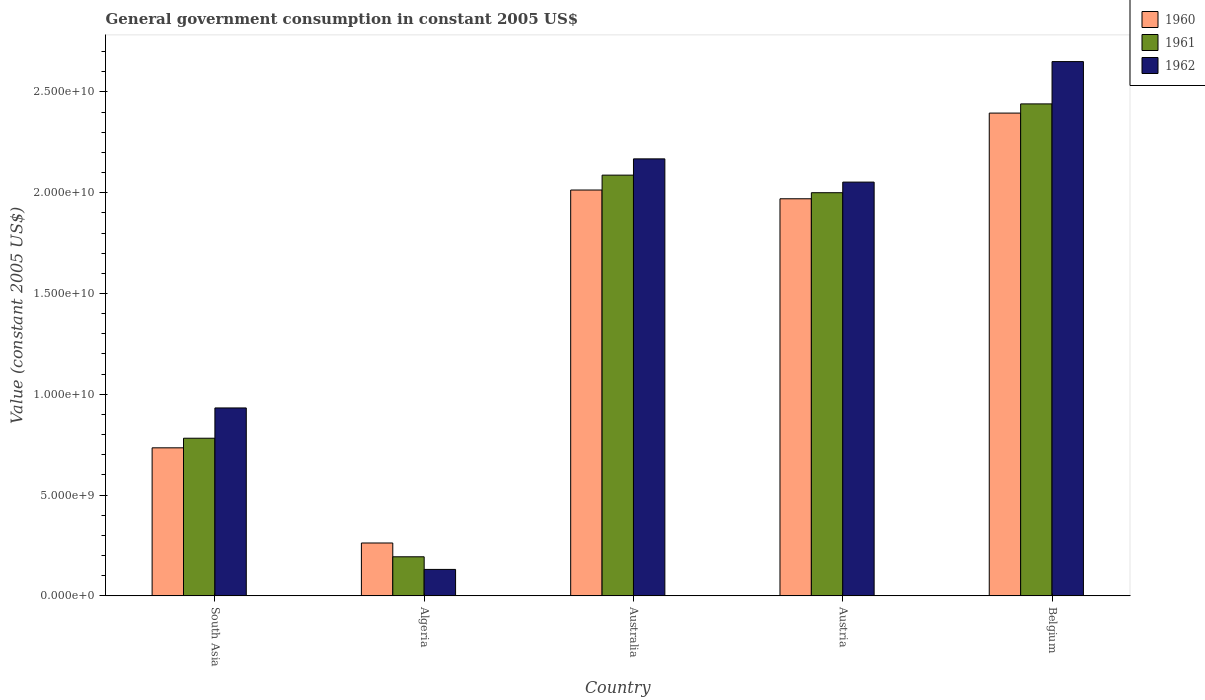How many different coloured bars are there?
Provide a succinct answer. 3. How many groups of bars are there?
Your answer should be very brief. 5. Are the number of bars on each tick of the X-axis equal?
Your answer should be compact. Yes. How many bars are there on the 4th tick from the right?
Provide a short and direct response. 3. In how many cases, is the number of bars for a given country not equal to the number of legend labels?
Your answer should be compact. 0. What is the government conusmption in 1960 in Belgium?
Your response must be concise. 2.40e+1. Across all countries, what is the maximum government conusmption in 1961?
Offer a very short reply. 2.44e+1. Across all countries, what is the minimum government conusmption in 1962?
Keep it short and to the point. 1.31e+09. In which country was the government conusmption in 1962 maximum?
Keep it short and to the point. Belgium. In which country was the government conusmption in 1960 minimum?
Your answer should be very brief. Algeria. What is the total government conusmption in 1960 in the graph?
Give a very brief answer. 7.38e+1. What is the difference between the government conusmption in 1961 in Australia and that in Austria?
Provide a short and direct response. 8.72e+08. What is the difference between the government conusmption in 1960 in Australia and the government conusmption in 1961 in Belgium?
Make the answer very short. -4.27e+09. What is the average government conusmption in 1962 per country?
Your answer should be compact. 1.59e+1. What is the difference between the government conusmption of/in 1962 and government conusmption of/in 1960 in South Asia?
Make the answer very short. 1.98e+09. In how many countries, is the government conusmption in 1962 greater than 12000000000 US$?
Make the answer very short. 3. What is the ratio of the government conusmption in 1960 in Algeria to that in Austria?
Give a very brief answer. 0.13. Is the government conusmption in 1960 in Austria less than that in South Asia?
Keep it short and to the point. No. Is the difference between the government conusmption in 1962 in Algeria and Austria greater than the difference between the government conusmption in 1960 in Algeria and Austria?
Ensure brevity in your answer.  No. What is the difference between the highest and the second highest government conusmption in 1960?
Offer a very short reply. 4.25e+09. What is the difference between the highest and the lowest government conusmption in 1960?
Offer a very short reply. 2.13e+1. Is the sum of the government conusmption in 1961 in Algeria and Austria greater than the maximum government conusmption in 1960 across all countries?
Offer a very short reply. No. What does the 2nd bar from the left in Austria represents?
Provide a short and direct response. 1961. Is it the case that in every country, the sum of the government conusmption in 1961 and government conusmption in 1962 is greater than the government conusmption in 1960?
Ensure brevity in your answer.  Yes. How many bars are there?
Your response must be concise. 15. How many countries are there in the graph?
Keep it short and to the point. 5. What is the difference between two consecutive major ticks on the Y-axis?
Your response must be concise. 5.00e+09. Does the graph contain any zero values?
Offer a terse response. No. Does the graph contain grids?
Ensure brevity in your answer.  No. Where does the legend appear in the graph?
Your response must be concise. Top right. How many legend labels are there?
Give a very brief answer. 3. How are the legend labels stacked?
Your response must be concise. Vertical. What is the title of the graph?
Provide a short and direct response. General government consumption in constant 2005 US$. What is the label or title of the Y-axis?
Give a very brief answer. Value (constant 2005 US$). What is the Value (constant 2005 US$) of 1960 in South Asia?
Your answer should be very brief. 7.34e+09. What is the Value (constant 2005 US$) of 1961 in South Asia?
Your answer should be compact. 7.82e+09. What is the Value (constant 2005 US$) of 1962 in South Asia?
Provide a short and direct response. 9.32e+09. What is the Value (constant 2005 US$) in 1960 in Algeria?
Ensure brevity in your answer.  2.62e+09. What is the Value (constant 2005 US$) in 1961 in Algeria?
Ensure brevity in your answer.  1.94e+09. What is the Value (constant 2005 US$) of 1962 in Algeria?
Provide a short and direct response. 1.31e+09. What is the Value (constant 2005 US$) of 1960 in Australia?
Your response must be concise. 2.01e+1. What is the Value (constant 2005 US$) in 1961 in Australia?
Your response must be concise. 2.09e+1. What is the Value (constant 2005 US$) of 1962 in Australia?
Make the answer very short. 2.17e+1. What is the Value (constant 2005 US$) in 1960 in Austria?
Make the answer very short. 1.97e+1. What is the Value (constant 2005 US$) of 1961 in Austria?
Offer a very short reply. 2.00e+1. What is the Value (constant 2005 US$) in 1962 in Austria?
Make the answer very short. 2.05e+1. What is the Value (constant 2005 US$) of 1960 in Belgium?
Ensure brevity in your answer.  2.40e+1. What is the Value (constant 2005 US$) in 1961 in Belgium?
Provide a succinct answer. 2.44e+1. What is the Value (constant 2005 US$) in 1962 in Belgium?
Offer a very short reply. 2.65e+1. Across all countries, what is the maximum Value (constant 2005 US$) of 1960?
Offer a terse response. 2.40e+1. Across all countries, what is the maximum Value (constant 2005 US$) in 1961?
Your answer should be compact. 2.44e+1. Across all countries, what is the maximum Value (constant 2005 US$) in 1962?
Make the answer very short. 2.65e+1. Across all countries, what is the minimum Value (constant 2005 US$) in 1960?
Your answer should be compact. 2.62e+09. Across all countries, what is the minimum Value (constant 2005 US$) of 1961?
Give a very brief answer. 1.94e+09. Across all countries, what is the minimum Value (constant 2005 US$) of 1962?
Give a very brief answer. 1.31e+09. What is the total Value (constant 2005 US$) of 1960 in the graph?
Ensure brevity in your answer.  7.38e+1. What is the total Value (constant 2005 US$) in 1961 in the graph?
Give a very brief answer. 7.50e+1. What is the total Value (constant 2005 US$) of 1962 in the graph?
Provide a short and direct response. 7.94e+1. What is the difference between the Value (constant 2005 US$) of 1960 in South Asia and that in Algeria?
Your response must be concise. 4.72e+09. What is the difference between the Value (constant 2005 US$) in 1961 in South Asia and that in Algeria?
Your answer should be compact. 5.88e+09. What is the difference between the Value (constant 2005 US$) in 1962 in South Asia and that in Algeria?
Your response must be concise. 8.01e+09. What is the difference between the Value (constant 2005 US$) in 1960 in South Asia and that in Australia?
Your answer should be very brief. -1.28e+1. What is the difference between the Value (constant 2005 US$) of 1961 in South Asia and that in Australia?
Provide a short and direct response. -1.31e+1. What is the difference between the Value (constant 2005 US$) of 1962 in South Asia and that in Australia?
Your answer should be very brief. -1.24e+1. What is the difference between the Value (constant 2005 US$) of 1960 in South Asia and that in Austria?
Offer a terse response. -1.24e+1. What is the difference between the Value (constant 2005 US$) of 1961 in South Asia and that in Austria?
Provide a succinct answer. -1.22e+1. What is the difference between the Value (constant 2005 US$) in 1962 in South Asia and that in Austria?
Offer a terse response. -1.12e+1. What is the difference between the Value (constant 2005 US$) of 1960 in South Asia and that in Belgium?
Give a very brief answer. -1.66e+1. What is the difference between the Value (constant 2005 US$) in 1961 in South Asia and that in Belgium?
Offer a terse response. -1.66e+1. What is the difference between the Value (constant 2005 US$) of 1962 in South Asia and that in Belgium?
Ensure brevity in your answer.  -1.72e+1. What is the difference between the Value (constant 2005 US$) in 1960 in Algeria and that in Australia?
Your answer should be very brief. -1.75e+1. What is the difference between the Value (constant 2005 US$) of 1961 in Algeria and that in Australia?
Make the answer very short. -1.89e+1. What is the difference between the Value (constant 2005 US$) in 1962 in Algeria and that in Australia?
Make the answer very short. -2.04e+1. What is the difference between the Value (constant 2005 US$) of 1960 in Algeria and that in Austria?
Ensure brevity in your answer.  -1.71e+1. What is the difference between the Value (constant 2005 US$) in 1961 in Algeria and that in Austria?
Keep it short and to the point. -1.81e+1. What is the difference between the Value (constant 2005 US$) of 1962 in Algeria and that in Austria?
Provide a short and direct response. -1.92e+1. What is the difference between the Value (constant 2005 US$) of 1960 in Algeria and that in Belgium?
Provide a short and direct response. -2.13e+1. What is the difference between the Value (constant 2005 US$) in 1961 in Algeria and that in Belgium?
Provide a short and direct response. -2.25e+1. What is the difference between the Value (constant 2005 US$) in 1962 in Algeria and that in Belgium?
Your answer should be very brief. -2.52e+1. What is the difference between the Value (constant 2005 US$) of 1960 in Australia and that in Austria?
Your response must be concise. 4.34e+08. What is the difference between the Value (constant 2005 US$) of 1961 in Australia and that in Austria?
Your answer should be very brief. 8.72e+08. What is the difference between the Value (constant 2005 US$) of 1962 in Australia and that in Austria?
Provide a short and direct response. 1.15e+09. What is the difference between the Value (constant 2005 US$) in 1960 in Australia and that in Belgium?
Offer a terse response. -3.82e+09. What is the difference between the Value (constant 2005 US$) in 1961 in Australia and that in Belgium?
Provide a succinct answer. -3.53e+09. What is the difference between the Value (constant 2005 US$) in 1962 in Australia and that in Belgium?
Keep it short and to the point. -4.83e+09. What is the difference between the Value (constant 2005 US$) in 1960 in Austria and that in Belgium?
Provide a succinct answer. -4.25e+09. What is the difference between the Value (constant 2005 US$) in 1961 in Austria and that in Belgium?
Your answer should be very brief. -4.41e+09. What is the difference between the Value (constant 2005 US$) in 1962 in Austria and that in Belgium?
Your response must be concise. -5.98e+09. What is the difference between the Value (constant 2005 US$) of 1960 in South Asia and the Value (constant 2005 US$) of 1961 in Algeria?
Give a very brief answer. 5.41e+09. What is the difference between the Value (constant 2005 US$) of 1960 in South Asia and the Value (constant 2005 US$) of 1962 in Algeria?
Offer a terse response. 6.03e+09. What is the difference between the Value (constant 2005 US$) in 1961 in South Asia and the Value (constant 2005 US$) in 1962 in Algeria?
Offer a terse response. 6.51e+09. What is the difference between the Value (constant 2005 US$) of 1960 in South Asia and the Value (constant 2005 US$) of 1961 in Australia?
Provide a short and direct response. -1.35e+1. What is the difference between the Value (constant 2005 US$) in 1960 in South Asia and the Value (constant 2005 US$) in 1962 in Australia?
Ensure brevity in your answer.  -1.43e+1. What is the difference between the Value (constant 2005 US$) of 1961 in South Asia and the Value (constant 2005 US$) of 1962 in Australia?
Provide a succinct answer. -1.39e+1. What is the difference between the Value (constant 2005 US$) in 1960 in South Asia and the Value (constant 2005 US$) in 1961 in Austria?
Make the answer very short. -1.27e+1. What is the difference between the Value (constant 2005 US$) in 1960 in South Asia and the Value (constant 2005 US$) in 1962 in Austria?
Provide a short and direct response. -1.32e+1. What is the difference between the Value (constant 2005 US$) in 1961 in South Asia and the Value (constant 2005 US$) in 1962 in Austria?
Make the answer very short. -1.27e+1. What is the difference between the Value (constant 2005 US$) in 1960 in South Asia and the Value (constant 2005 US$) in 1961 in Belgium?
Offer a very short reply. -1.71e+1. What is the difference between the Value (constant 2005 US$) in 1960 in South Asia and the Value (constant 2005 US$) in 1962 in Belgium?
Offer a very short reply. -1.92e+1. What is the difference between the Value (constant 2005 US$) of 1961 in South Asia and the Value (constant 2005 US$) of 1962 in Belgium?
Offer a very short reply. -1.87e+1. What is the difference between the Value (constant 2005 US$) of 1960 in Algeria and the Value (constant 2005 US$) of 1961 in Australia?
Your answer should be very brief. -1.83e+1. What is the difference between the Value (constant 2005 US$) in 1960 in Algeria and the Value (constant 2005 US$) in 1962 in Australia?
Keep it short and to the point. -1.91e+1. What is the difference between the Value (constant 2005 US$) in 1961 in Algeria and the Value (constant 2005 US$) in 1962 in Australia?
Offer a terse response. -1.97e+1. What is the difference between the Value (constant 2005 US$) in 1960 in Algeria and the Value (constant 2005 US$) in 1961 in Austria?
Give a very brief answer. -1.74e+1. What is the difference between the Value (constant 2005 US$) of 1960 in Algeria and the Value (constant 2005 US$) of 1962 in Austria?
Provide a short and direct response. -1.79e+1. What is the difference between the Value (constant 2005 US$) in 1961 in Algeria and the Value (constant 2005 US$) in 1962 in Austria?
Your answer should be compact. -1.86e+1. What is the difference between the Value (constant 2005 US$) of 1960 in Algeria and the Value (constant 2005 US$) of 1961 in Belgium?
Your answer should be compact. -2.18e+1. What is the difference between the Value (constant 2005 US$) in 1960 in Algeria and the Value (constant 2005 US$) in 1962 in Belgium?
Provide a short and direct response. -2.39e+1. What is the difference between the Value (constant 2005 US$) in 1961 in Algeria and the Value (constant 2005 US$) in 1962 in Belgium?
Keep it short and to the point. -2.46e+1. What is the difference between the Value (constant 2005 US$) of 1960 in Australia and the Value (constant 2005 US$) of 1961 in Austria?
Provide a short and direct response. 1.33e+08. What is the difference between the Value (constant 2005 US$) of 1960 in Australia and the Value (constant 2005 US$) of 1962 in Austria?
Provide a short and direct response. -3.94e+08. What is the difference between the Value (constant 2005 US$) of 1961 in Australia and the Value (constant 2005 US$) of 1962 in Austria?
Your response must be concise. 3.45e+08. What is the difference between the Value (constant 2005 US$) of 1960 in Australia and the Value (constant 2005 US$) of 1961 in Belgium?
Offer a terse response. -4.27e+09. What is the difference between the Value (constant 2005 US$) of 1960 in Australia and the Value (constant 2005 US$) of 1962 in Belgium?
Your answer should be compact. -6.37e+09. What is the difference between the Value (constant 2005 US$) of 1961 in Australia and the Value (constant 2005 US$) of 1962 in Belgium?
Give a very brief answer. -5.63e+09. What is the difference between the Value (constant 2005 US$) in 1960 in Austria and the Value (constant 2005 US$) in 1961 in Belgium?
Provide a succinct answer. -4.71e+09. What is the difference between the Value (constant 2005 US$) in 1960 in Austria and the Value (constant 2005 US$) in 1962 in Belgium?
Your answer should be compact. -6.81e+09. What is the difference between the Value (constant 2005 US$) of 1961 in Austria and the Value (constant 2005 US$) of 1962 in Belgium?
Offer a terse response. -6.51e+09. What is the average Value (constant 2005 US$) of 1960 per country?
Your response must be concise. 1.48e+1. What is the average Value (constant 2005 US$) in 1961 per country?
Provide a short and direct response. 1.50e+1. What is the average Value (constant 2005 US$) in 1962 per country?
Your response must be concise. 1.59e+1. What is the difference between the Value (constant 2005 US$) of 1960 and Value (constant 2005 US$) of 1961 in South Asia?
Give a very brief answer. -4.76e+08. What is the difference between the Value (constant 2005 US$) in 1960 and Value (constant 2005 US$) in 1962 in South Asia?
Provide a short and direct response. -1.98e+09. What is the difference between the Value (constant 2005 US$) in 1961 and Value (constant 2005 US$) in 1962 in South Asia?
Your answer should be very brief. -1.50e+09. What is the difference between the Value (constant 2005 US$) in 1960 and Value (constant 2005 US$) in 1961 in Algeria?
Give a very brief answer. 6.84e+08. What is the difference between the Value (constant 2005 US$) in 1960 and Value (constant 2005 US$) in 1962 in Algeria?
Provide a succinct answer. 1.31e+09. What is the difference between the Value (constant 2005 US$) in 1961 and Value (constant 2005 US$) in 1962 in Algeria?
Your answer should be very brief. 6.27e+08. What is the difference between the Value (constant 2005 US$) of 1960 and Value (constant 2005 US$) of 1961 in Australia?
Provide a short and direct response. -7.39e+08. What is the difference between the Value (constant 2005 US$) in 1960 and Value (constant 2005 US$) in 1962 in Australia?
Offer a very short reply. -1.55e+09. What is the difference between the Value (constant 2005 US$) in 1961 and Value (constant 2005 US$) in 1962 in Australia?
Ensure brevity in your answer.  -8.07e+08. What is the difference between the Value (constant 2005 US$) in 1960 and Value (constant 2005 US$) in 1961 in Austria?
Your answer should be compact. -3.01e+08. What is the difference between the Value (constant 2005 US$) in 1960 and Value (constant 2005 US$) in 1962 in Austria?
Give a very brief answer. -8.27e+08. What is the difference between the Value (constant 2005 US$) in 1961 and Value (constant 2005 US$) in 1962 in Austria?
Offer a very short reply. -5.26e+08. What is the difference between the Value (constant 2005 US$) in 1960 and Value (constant 2005 US$) in 1961 in Belgium?
Your answer should be very brief. -4.56e+08. What is the difference between the Value (constant 2005 US$) of 1960 and Value (constant 2005 US$) of 1962 in Belgium?
Make the answer very short. -2.55e+09. What is the difference between the Value (constant 2005 US$) of 1961 and Value (constant 2005 US$) of 1962 in Belgium?
Your response must be concise. -2.10e+09. What is the ratio of the Value (constant 2005 US$) of 1960 in South Asia to that in Algeria?
Your response must be concise. 2.8. What is the ratio of the Value (constant 2005 US$) in 1961 in South Asia to that in Algeria?
Provide a succinct answer. 4.04. What is the ratio of the Value (constant 2005 US$) in 1962 in South Asia to that in Algeria?
Ensure brevity in your answer.  7.11. What is the ratio of the Value (constant 2005 US$) in 1960 in South Asia to that in Australia?
Offer a very short reply. 0.36. What is the ratio of the Value (constant 2005 US$) of 1961 in South Asia to that in Australia?
Ensure brevity in your answer.  0.37. What is the ratio of the Value (constant 2005 US$) in 1962 in South Asia to that in Australia?
Your answer should be very brief. 0.43. What is the ratio of the Value (constant 2005 US$) of 1960 in South Asia to that in Austria?
Offer a very short reply. 0.37. What is the ratio of the Value (constant 2005 US$) of 1961 in South Asia to that in Austria?
Ensure brevity in your answer.  0.39. What is the ratio of the Value (constant 2005 US$) in 1962 in South Asia to that in Austria?
Your response must be concise. 0.45. What is the ratio of the Value (constant 2005 US$) in 1960 in South Asia to that in Belgium?
Ensure brevity in your answer.  0.31. What is the ratio of the Value (constant 2005 US$) of 1961 in South Asia to that in Belgium?
Your response must be concise. 0.32. What is the ratio of the Value (constant 2005 US$) of 1962 in South Asia to that in Belgium?
Provide a succinct answer. 0.35. What is the ratio of the Value (constant 2005 US$) of 1960 in Algeria to that in Australia?
Your response must be concise. 0.13. What is the ratio of the Value (constant 2005 US$) of 1961 in Algeria to that in Australia?
Give a very brief answer. 0.09. What is the ratio of the Value (constant 2005 US$) of 1962 in Algeria to that in Australia?
Give a very brief answer. 0.06. What is the ratio of the Value (constant 2005 US$) of 1960 in Algeria to that in Austria?
Offer a very short reply. 0.13. What is the ratio of the Value (constant 2005 US$) in 1961 in Algeria to that in Austria?
Ensure brevity in your answer.  0.1. What is the ratio of the Value (constant 2005 US$) of 1962 in Algeria to that in Austria?
Give a very brief answer. 0.06. What is the ratio of the Value (constant 2005 US$) in 1960 in Algeria to that in Belgium?
Give a very brief answer. 0.11. What is the ratio of the Value (constant 2005 US$) of 1961 in Algeria to that in Belgium?
Provide a succinct answer. 0.08. What is the ratio of the Value (constant 2005 US$) in 1962 in Algeria to that in Belgium?
Your answer should be very brief. 0.05. What is the ratio of the Value (constant 2005 US$) of 1960 in Australia to that in Austria?
Give a very brief answer. 1.02. What is the ratio of the Value (constant 2005 US$) in 1961 in Australia to that in Austria?
Keep it short and to the point. 1.04. What is the ratio of the Value (constant 2005 US$) in 1962 in Australia to that in Austria?
Offer a very short reply. 1.06. What is the ratio of the Value (constant 2005 US$) in 1960 in Australia to that in Belgium?
Offer a very short reply. 0.84. What is the ratio of the Value (constant 2005 US$) in 1961 in Australia to that in Belgium?
Offer a terse response. 0.86. What is the ratio of the Value (constant 2005 US$) in 1962 in Australia to that in Belgium?
Your answer should be compact. 0.82. What is the ratio of the Value (constant 2005 US$) in 1960 in Austria to that in Belgium?
Your response must be concise. 0.82. What is the ratio of the Value (constant 2005 US$) of 1961 in Austria to that in Belgium?
Provide a short and direct response. 0.82. What is the ratio of the Value (constant 2005 US$) in 1962 in Austria to that in Belgium?
Ensure brevity in your answer.  0.77. What is the difference between the highest and the second highest Value (constant 2005 US$) in 1960?
Give a very brief answer. 3.82e+09. What is the difference between the highest and the second highest Value (constant 2005 US$) of 1961?
Ensure brevity in your answer.  3.53e+09. What is the difference between the highest and the second highest Value (constant 2005 US$) of 1962?
Your response must be concise. 4.83e+09. What is the difference between the highest and the lowest Value (constant 2005 US$) in 1960?
Your answer should be very brief. 2.13e+1. What is the difference between the highest and the lowest Value (constant 2005 US$) in 1961?
Offer a terse response. 2.25e+1. What is the difference between the highest and the lowest Value (constant 2005 US$) in 1962?
Your answer should be compact. 2.52e+1. 